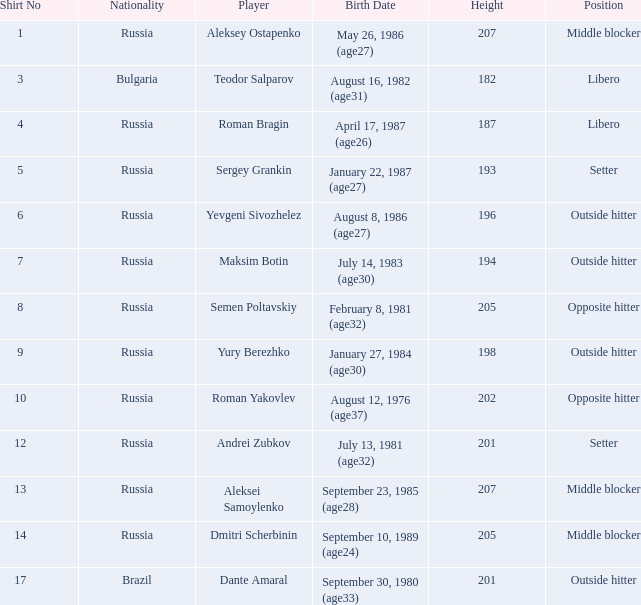What is Roman Bragin's position?  Libero. 